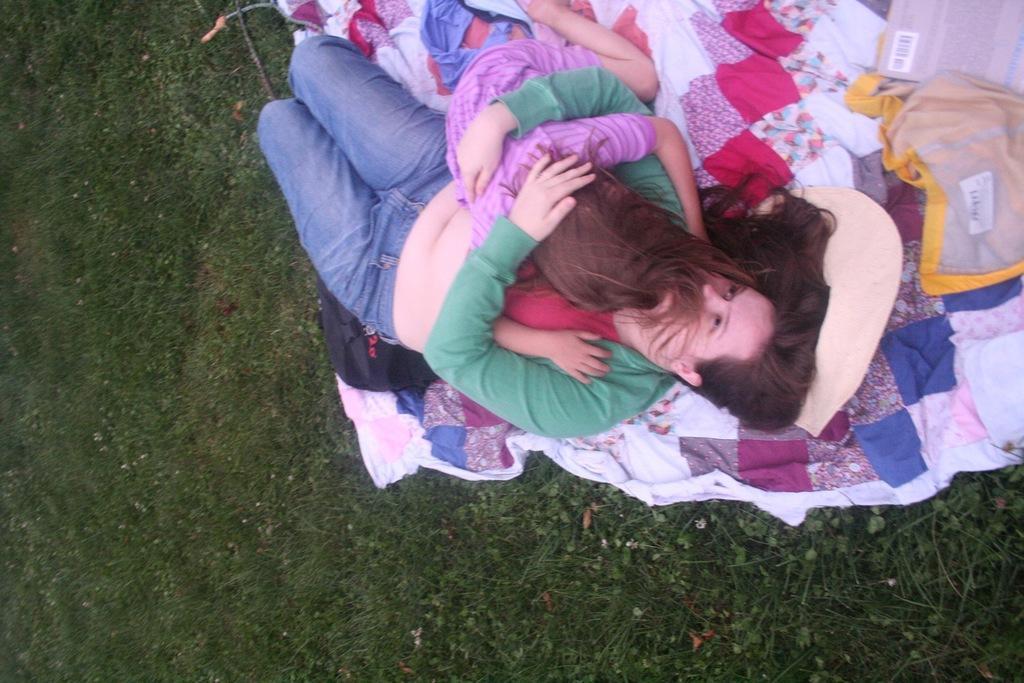Describe this image in one or two sentences. In the picture I can see a woman wearing green color T-shirt is carrying a child and lying on the grass. Here we can see some objects. 